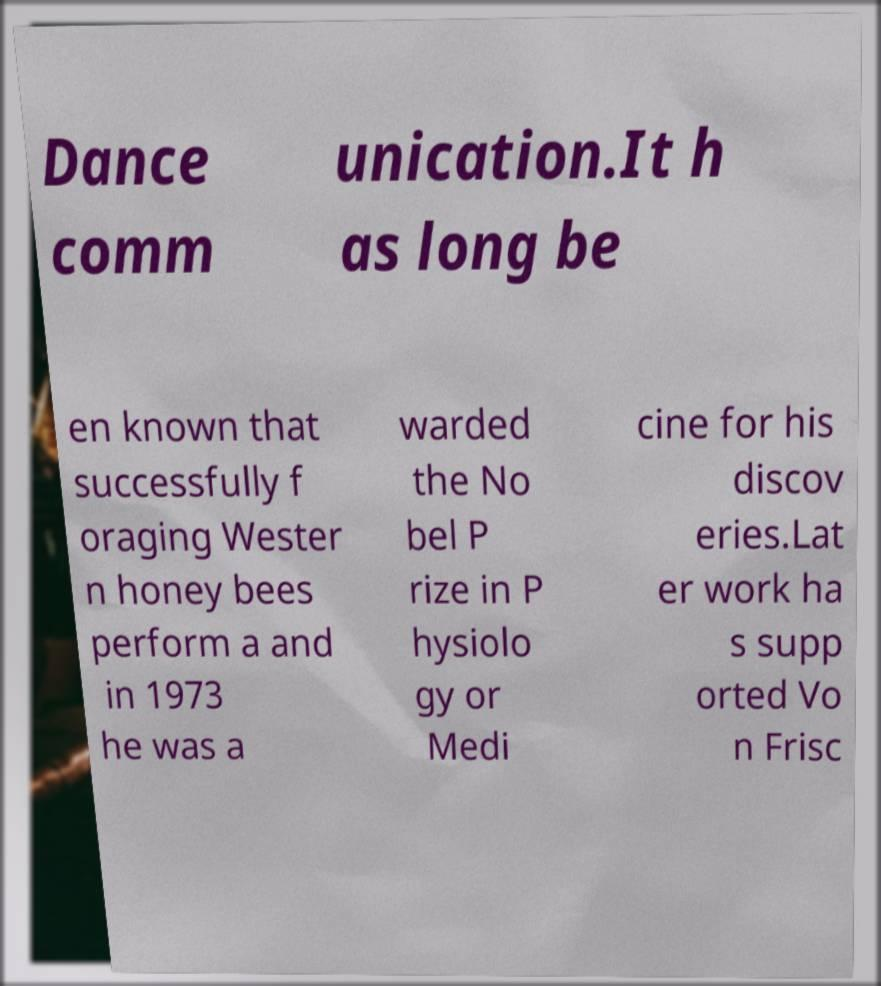Please identify and transcribe the text found in this image. Dance comm unication.It h as long be en known that successfully f oraging Wester n honey bees perform a and in 1973 he was a warded the No bel P rize in P hysiolo gy or Medi cine for his discov eries.Lat er work ha s supp orted Vo n Frisc 